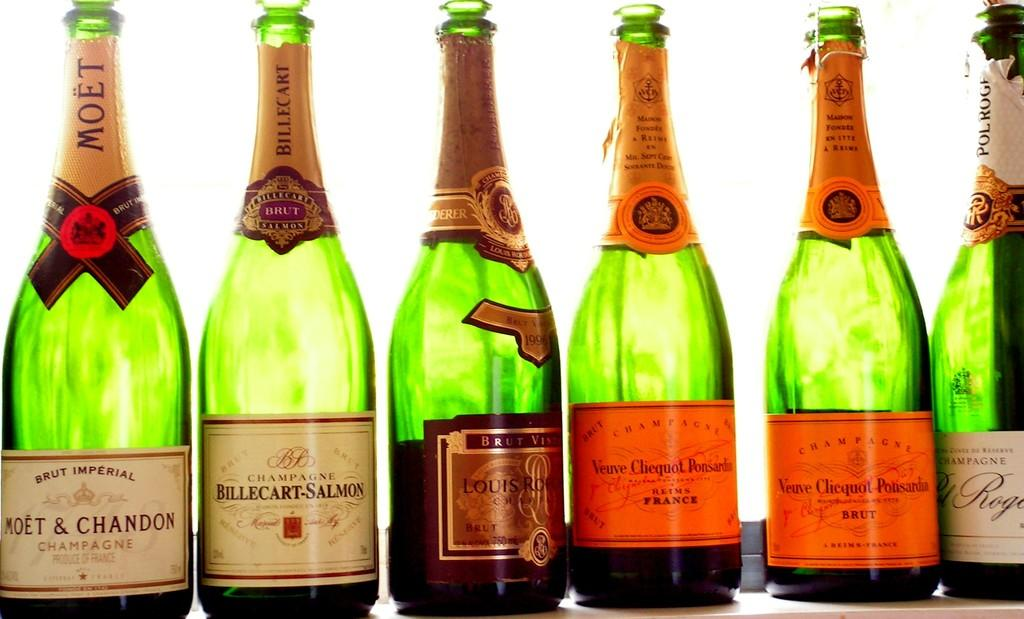Provide a one-sentence caption for the provided image. six bottles of champagne, one of which si moet and chandon. 